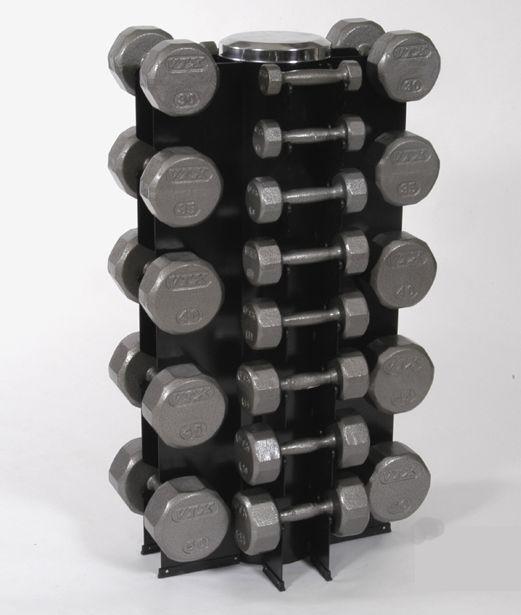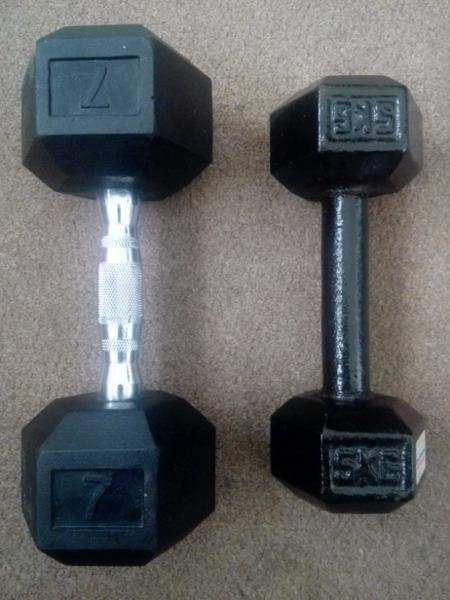The first image is the image on the left, the second image is the image on the right. Given the left and right images, does the statement "The weights on the rack in the image on the left are round." hold true? Answer yes or no. Yes. The first image is the image on the left, the second image is the image on the right. Assess this claim about the two images: "The right image contains sets of weights stacked into three rows.". Correct or not? Answer yes or no. No. 